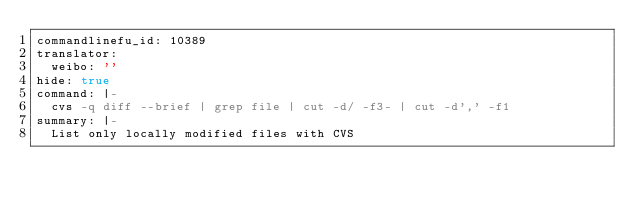<code> <loc_0><loc_0><loc_500><loc_500><_YAML_>commandlinefu_id: 10389
translator:
  weibo: ''
hide: true
command: |-
  cvs -q diff --brief | grep file | cut -d/ -f3- | cut -d',' -f1
summary: |-
  List only locally modified files with CVS
</code> 